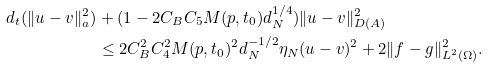<formula> <loc_0><loc_0><loc_500><loc_500>d _ { t } ( \| u - v \| ^ { 2 } _ { a } ) & + ( 1 - 2 C _ { B } C _ { 5 } M ( p , t _ { 0 } ) d ^ { 1 / 4 } _ { N } ) \| u - v \| ^ { 2 } _ { D ( A ) } \\ & \leq 2 C ^ { 2 } _ { B } C ^ { 2 } _ { 4 } M ( p , t _ { 0 } ) ^ { 2 } d ^ { - 1 / 2 } _ { N } \eta _ { N } ( u - v ) ^ { 2 } + 2 \| f - g \| ^ { 2 } _ { L ^ { 2 } ( \Omega ) } .</formula> 